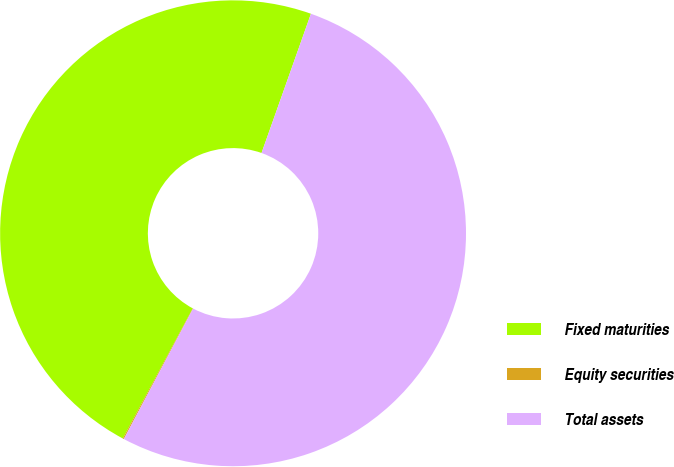Convert chart. <chart><loc_0><loc_0><loc_500><loc_500><pie_chart><fcel>Fixed maturities<fcel>Equity securities<fcel>Total assets<nl><fcel>47.58%<fcel>0.08%<fcel>52.34%<nl></chart> 